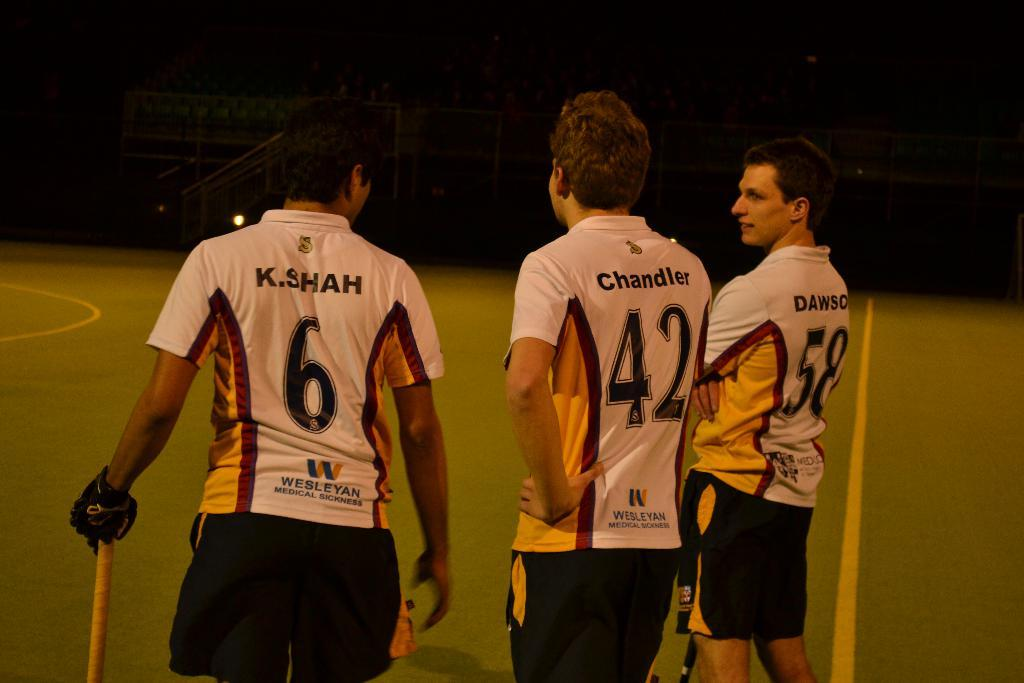<image>
Render a clear and concise summary of the photo. Three athletes wearing the uniforms are standing around as no 58 looks to the left. 